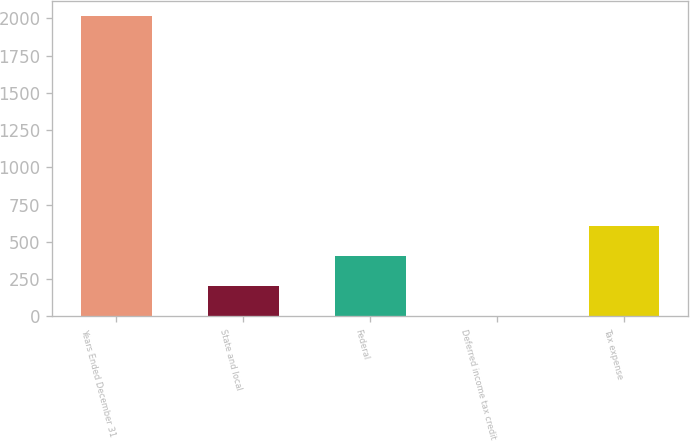<chart> <loc_0><loc_0><loc_500><loc_500><bar_chart><fcel>Years Ended December 31<fcel>State and local<fcel>Federal<fcel>Deferred income tax credit<fcel>Tax expense<nl><fcel>2013<fcel>204<fcel>405<fcel>3<fcel>606<nl></chart> 